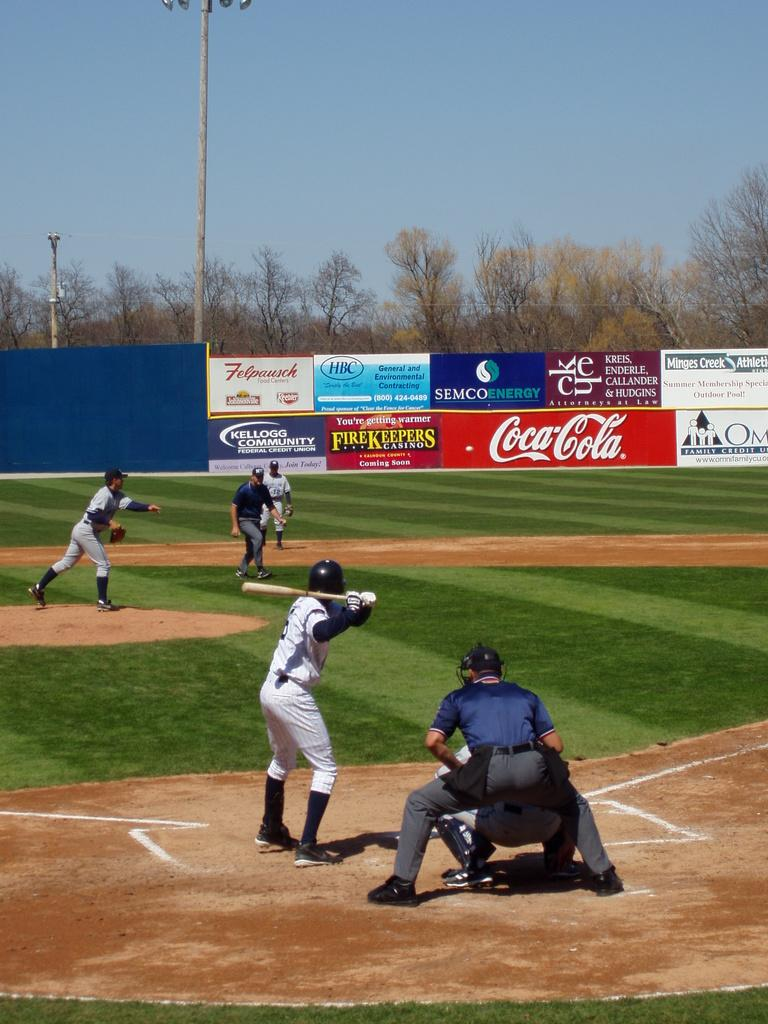Provide a one-sentence caption for the provided image. A baseball game being played with a Coca-Cola billboard in the background. 